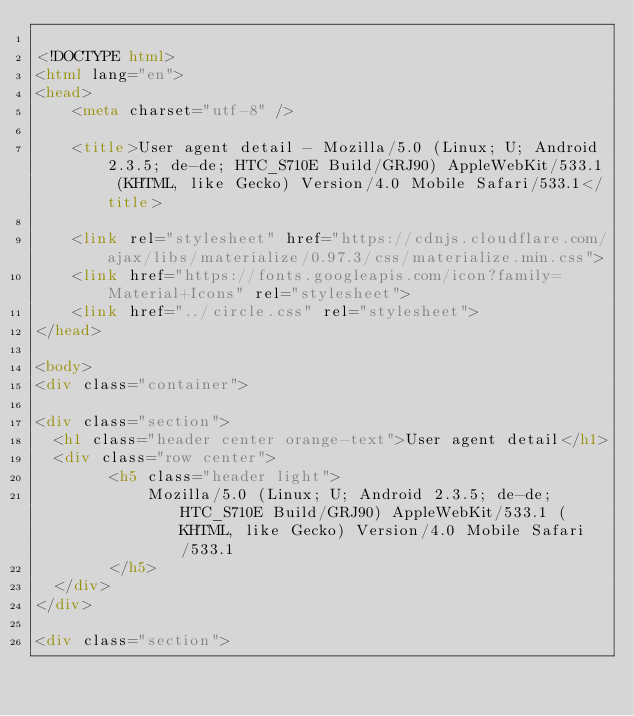Convert code to text. <code><loc_0><loc_0><loc_500><loc_500><_HTML_>
<!DOCTYPE html>
<html lang="en">
<head>
    <meta charset="utf-8" />
            
    <title>User agent detail - Mozilla/5.0 (Linux; U; Android 2.3.5; de-de; HTC_S710E Build/GRJ90) AppleWebKit/533.1 (KHTML, like Gecko) Version/4.0 Mobile Safari/533.1</title>
        
    <link rel="stylesheet" href="https://cdnjs.cloudflare.com/ajax/libs/materialize/0.97.3/css/materialize.min.css">
    <link href="https://fonts.googleapis.com/icon?family=Material+Icons" rel="stylesheet">
    <link href="../circle.css" rel="stylesheet">
</head>
        
<body>
<div class="container">
    
<div class="section">
	<h1 class="header center orange-text">User agent detail</h1>
	<div class="row center">
        <h5 class="header light">
            Mozilla/5.0 (Linux; U; Android 2.3.5; de-de; HTC_S710E Build/GRJ90) AppleWebKit/533.1 (KHTML, like Gecko) Version/4.0 Mobile Safari/533.1
        </h5>
	</div>
</div>   

<div class="section"></code> 